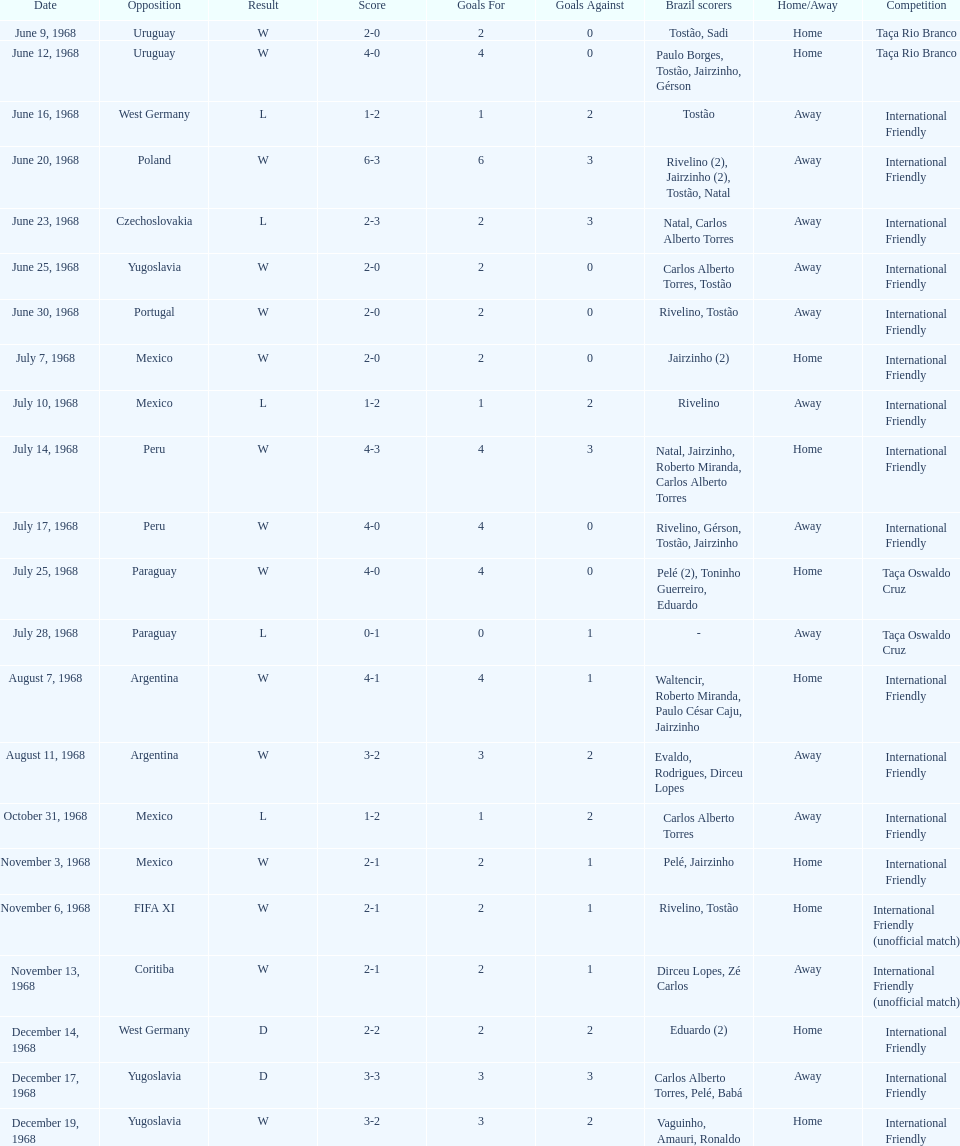What year has the highest scoring game? 1968. 